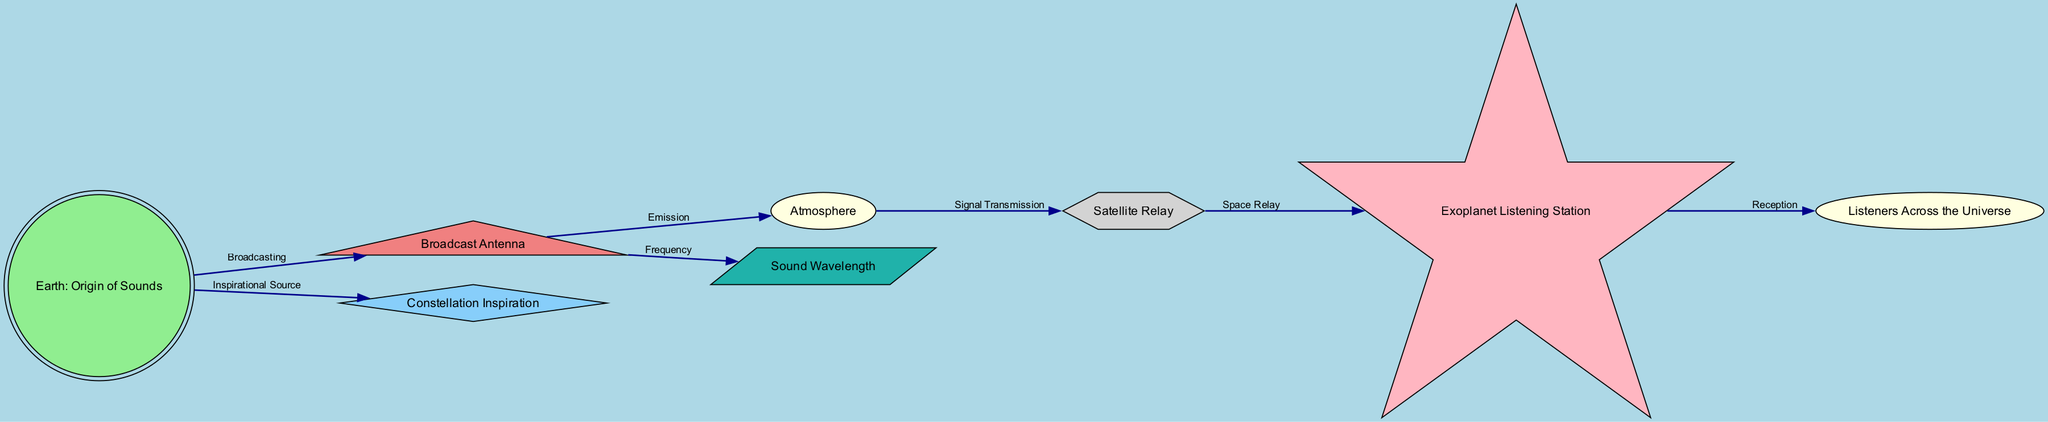What is the starting point of TV On The Radio's music journey? The diagram indicates that Earth is the origin of sounds, where TV On The Radio was formed in New York. Thus, the journey begins at Earth.
Answer: Earth: Origin of Sounds How many nodes are present in the diagram? The diagram displays a total of 8 nodes, each representing different elements in the journey of TV On The Radio's music.
Answer: 8 What is the relationship between the Broadcast Antenna and the Atmosphere? The diagram shows an edge connecting Broadcast Antenna to Atmosphere with the label "Emission," indicating that the music is emitted into the atmosphere from the antenna.
Answer: Emission What does the Constellation represent in this diagram? According to the description in the diagram, the Constellation serves as an inspirational source for the musical creations of TV On The Radio, indicating a creative influence derived from celestial bodies.
Answer: Inspirational Source What is the signal transmission method from the Atmosphere to the Satellite? The diagram specifies the relationship between the Atmosphere and the Satellite with the label "Signal Transmission." This explains how sound waves are transmitted through Earth's atmosphere to reach the satellite.
Answer: Signal Transmission Which node represents the place where the music is received in the universe? The diagram includes a node named Exoplanet Listening Station, which signifies the hypothetical exoplanet that receives the signals sent from Earth through satellites.
Answer: Exoplanet Listening Station What is the final destination for the music signals in the journey? The journey culminates at the "Listeners Across the Universe," which denotes all fans of TV On The Radio who receive the music signals, whether on Earth or potentially beyond.
Answer: Listeners Across the Universe What is the frequency with which the music travels through space? The diagram indicates a connection from Broadcast Antenna to Wavelength, labeled "Frequency," thereby denoting that this is the aspect of sound that carries music through the cosmos.
Answer: Frequency 